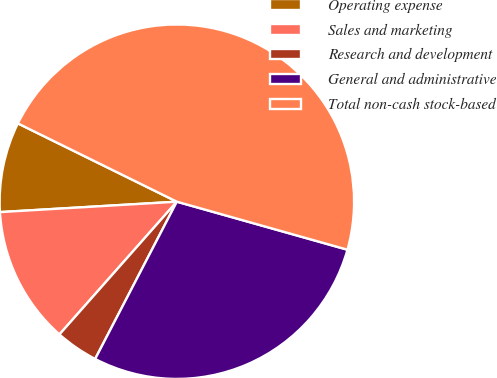Convert chart. <chart><loc_0><loc_0><loc_500><loc_500><pie_chart><fcel>Operating expense<fcel>Sales and marketing<fcel>Research and development<fcel>General and administrative<fcel>Total non-cash stock-based<nl><fcel>8.22%<fcel>12.54%<fcel>3.9%<fcel>28.26%<fcel>47.09%<nl></chart> 